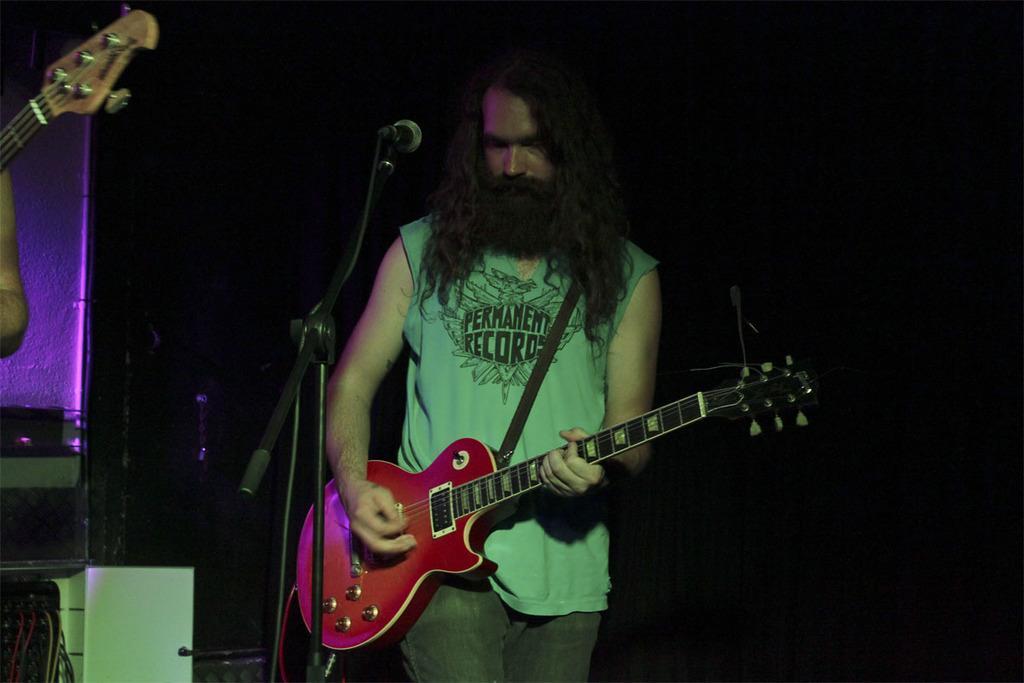Could you give a brief overview of what you see in this image? In this image I see a man who is holding a guitar and he is standing in front of a mic and I can also see that there is a person's hand over here and a guitar. 